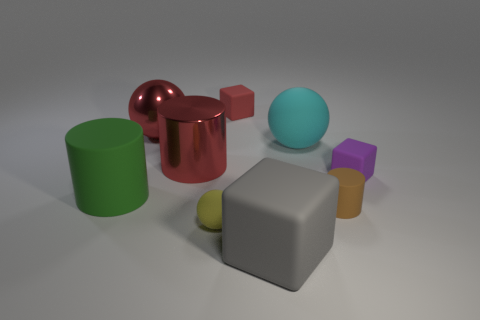Subtract all purple cylinders. Subtract all gray balls. How many cylinders are left? 3 Subtract all cylinders. How many objects are left? 6 Subtract all cyan cylinders. Subtract all yellow spheres. How many objects are left? 8 Add 1 red metallic balls. How many red metallic balls are left? 2 Add 9 small red things. How many small red things exist? 10 Subtract 0 green blocks. How many objects are left? 9 